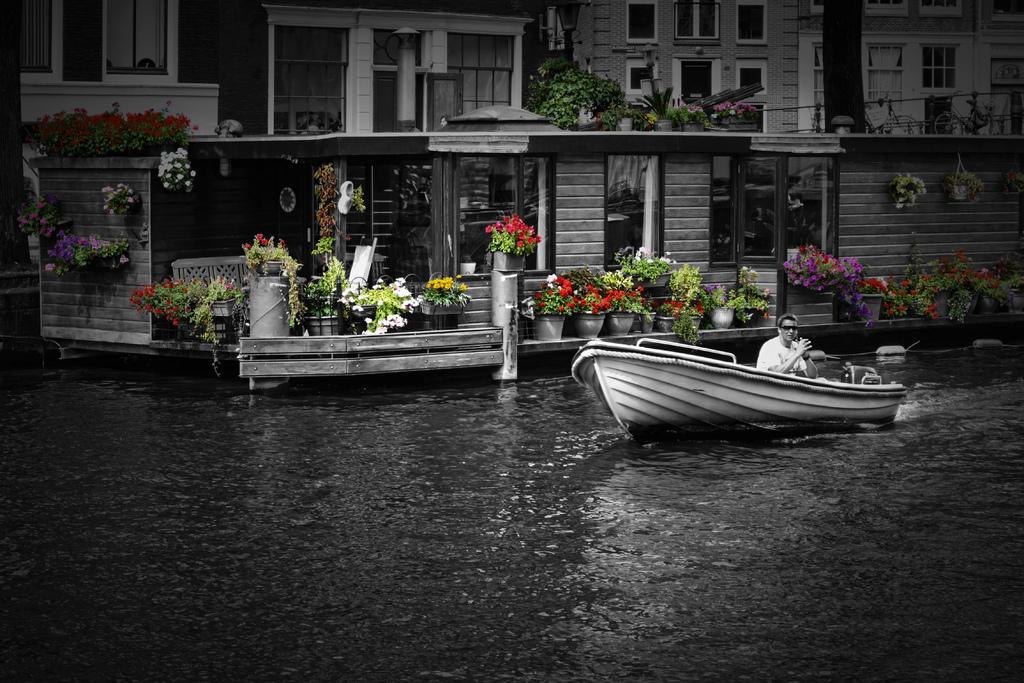How would you summarize this image in a sentence or two? In this image, there is an outside view. In the foreground, there is a person on the boat which is floating on the water. There are some flowers pots in the middle of the image. In the background, there is a building. 